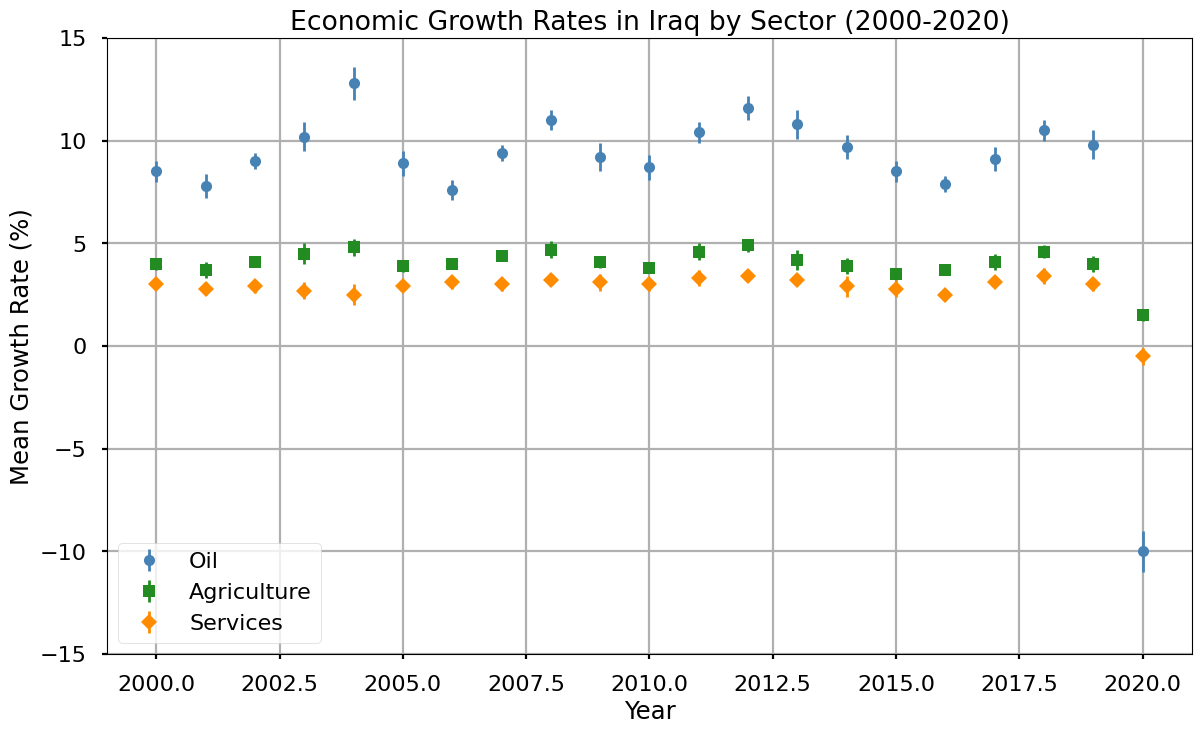Which sector had the highest mean growth rate in 2008? By examining the plot, identify the sector with the highest data point in 2008. The oil sector shows the highest mean growth rate for that year.
Answer: Oil What is the difference in mean growth rates between the oil sector and agriculture sector in 2020? Identify the data points for both sectors in 2020 from the plot. The oil sector is at -10.0%, and the agriculture sector is at 1.5%. Calculate the difference. -10.0% - 1.5% = -11.5%.
Answer: -11.5% In which years did the services sector show a decline in mean growth rate? Look at the points for the services sector below 0%. The services sector shows declines in 2003, 2004, 2005, 2014, 2015, 2016, and 2020.
Answer: 2003, 2004, 2005, 2014, 2015, 2016, 2020 By how much did the mean growth rate of the oil sector increase from 2003 to 2004? From the plot, find the oil sector data points for 2003 (10.2%) and 2004 (12.8%). Subtract the 2003 value from the 2004 value. 12.8% - 10.2% = 2.6%.
Answer: 2.6% Which sector experienced the lowest mean growth rate in 2020? Identify the lowest point across all sectors for 2020. The services sector has the lowest growth rate at -0.5%.
Answer: Services Compare the mean growth rates of the oil and services sectors in 2011. Which one is higher and by how much? From the plot, find the mean growth rates for both sectors in 2011 (oil: 10.4%, services: 3.3%). Subtract the services rate from the oil rate. 10.4% - 3.3% = 7.1%.
Answer: Oil by 7.1% How did the mean growth rate of agriculture change from 2000 to 2010? Calculate the percentage change. Find the growth rates for agriculture in 2000 (4%) and 2010 (3.8%). Use the formula [(final - initial) / initial] * 100. (3.8% - 4%) / 4% * 100 = -5%.
Answer: -5% What is the average mean growth rate of the oil sector for the years 2000, 2001, and 2002? Identify the oil sector averages for these years (2000: 8.5%, 2001: 7.8%, 2002: 9.0%). Find the average: (8.5% + 7.8% + 9.0%) / 3 = 8.43%.
Answer: 8.43% For the years 2010 to 2020, what is the trend observed in the mean growth rate of the services sector? Examine the services sector data points from 2010 to 2020. Observe if they generally increase, decrease, or show no clear trend. The data points show a fluctuating but slightly decreasing trend that ends in a significant decline in 2020.
Answer: Slightly decreasing trend ending in a significant decline Which year shows the highest mean growth rate for the agriculture sector? Identify the highest data point for the agriculture sector. The year 2012 shows the highest mean growth rate at 4.9%.
Answer: 2012 